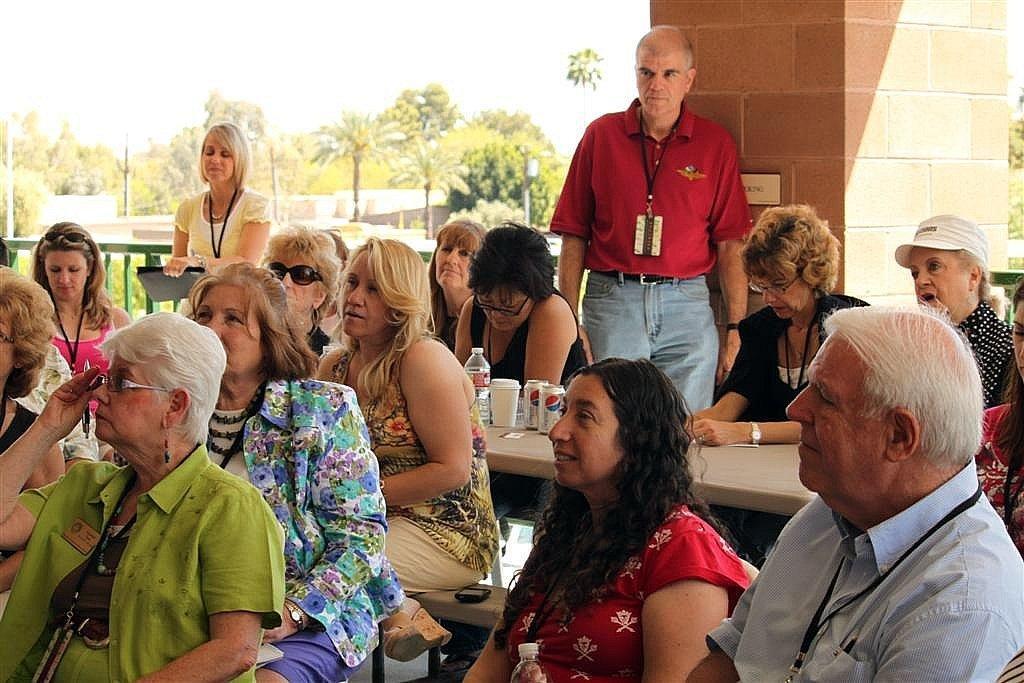Describe this image in one or two sentences. In this image we can see group of persons sitting. Behind the persons we can see a person standing. In the middle of the persons we can see few objects on a table. Behind the persons we can see a pillar, fencing and a group of trees. At the top we can see the sky. 